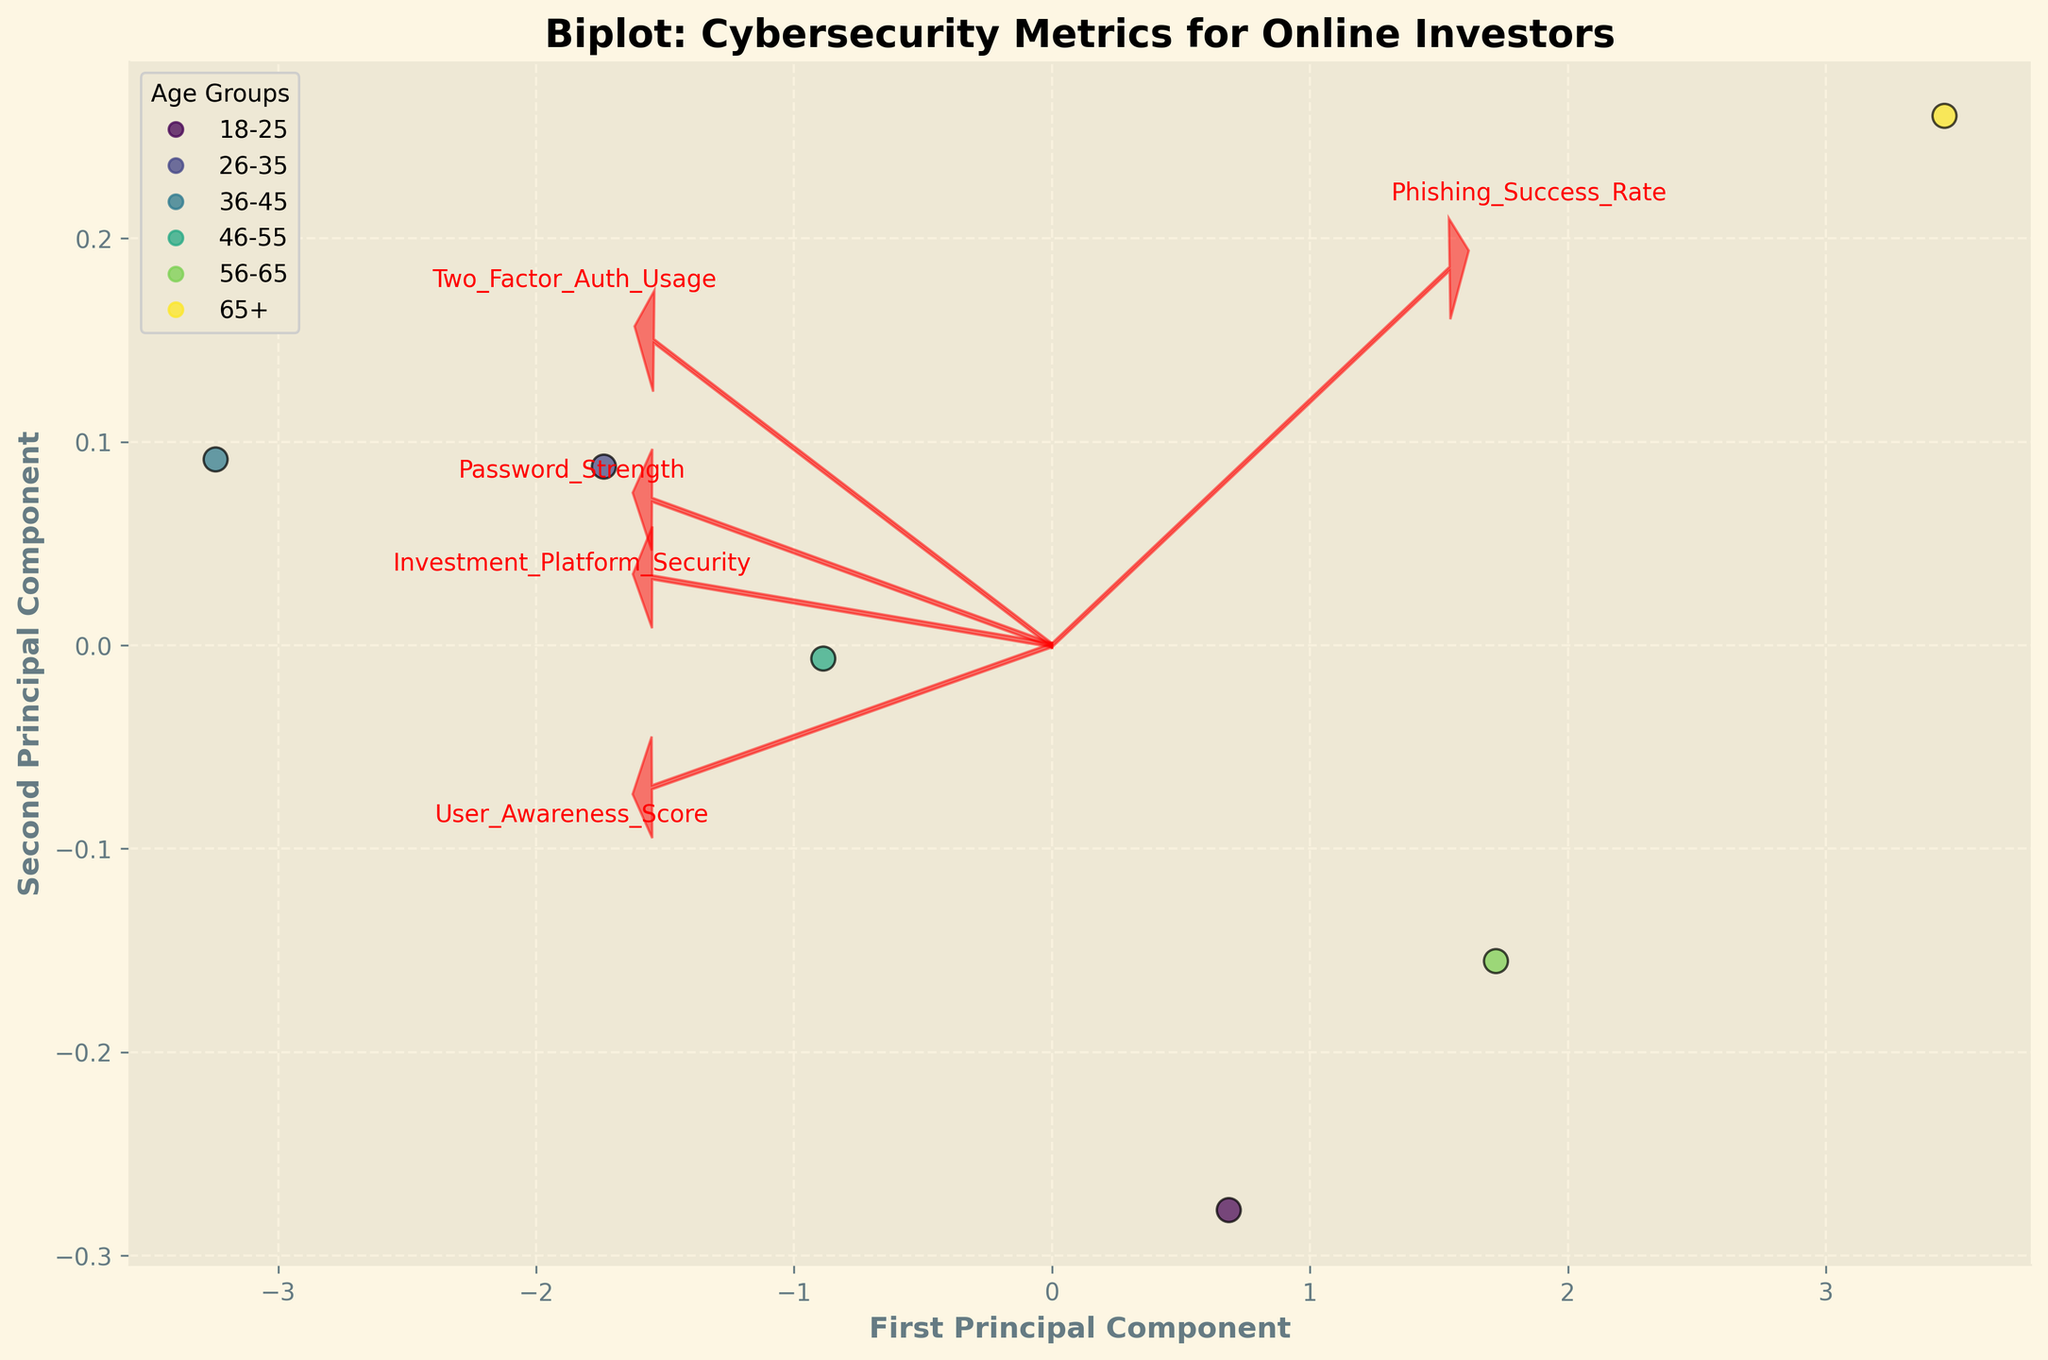What's the title of the plot? The title is usually found at the top of the plot and is intended to give a brief description of what the plot represents.
Answer: Biplot: Cybersecurity Metrics for Online Investors How many age groups are presented in the plot? The number of unique data points or legend entries showing different colors can help identify this.
Answer: 6 Which age group has the highest phishing success rate? Look at the position of the points in relation to the Phishing_Success_Rate vector (arrow); the group at the most end of this arrow likely has the highest rate.
Answer: 65+ What is the color representing the 36-45 age group in the plot? The legend, which associates each age group with a unique color, can be used to identify this.
Answer: Not specified in the data Which feature vector appears to relate most closely to the second principal component? Analyze the directions of the arrows; the feature with an arrow pointing most closely parallel to the second principal component (y-axis) is the related one.
Answer: User_Awareness_Score Which feature seems to align most with the first principal component? The feature with the arrow closest to parallel orientation with the first principal component (x-axis) will be the answer.
Answer: Two_Factor_Auth_Usage How does User Awareness Score correlate with Phishing Success Rate across age groups? Observe the directions of the feature vectors for User_Awareness_Score and Phishing_Success_Rate; if they point in opposite directions, there's a negative correlation.
Answer: Negatively correlated Which age group is closest to the origin in the plot? Look at the data points' positions relative to the origin (0,0); the one closest to this point is the answer.
Answer: Not specified in the data What does a longer arrow represent in this biplot? Longer arrows typically indicate that the feature has a stronger contribution to the variance represented by the principal components.
Answer: Stronger contribution to variance Which feature vectors indicate positive association among them based on their directions? Check if the arrows point in similar directions; features with arrows pointing in approximately the same direction are positively associated.
Answer: Investment_Platform_Security and Password_Strength 